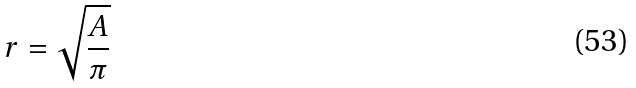Convert formula to latex. <formula><loc_0><loc_0><loc_500><loc_500>r = \sqrt { \frac { A } { \pi } }</formula> 